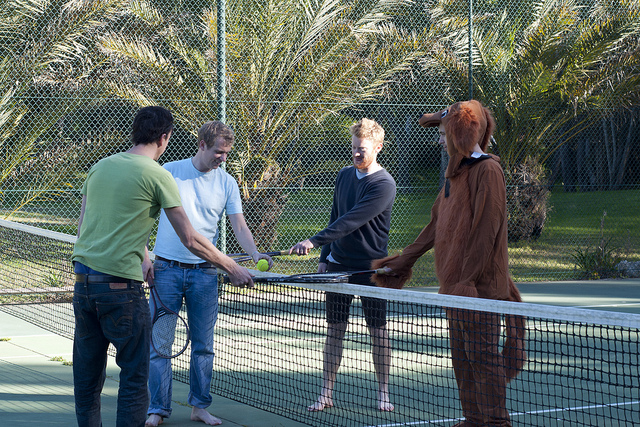Describe the mood of the scene in the image. The mood in the image appears to be light-hearted and fun. The presence of a person in a dog costume adds a playful and humorous element, suggesting that the group is enjoying their time together. The casual attire of the other individuals also indicates a relaxed atmosphere. If you were to write a short story based on this image, what would the plot be? In a small, sunny town, a group of friends gathers every Sunday morning for a match on the local tennis court. This Sunday was special; it was Tim's birthday, and as a surprise, his friends convinced him to wear a dog costume for the game. Laughter echoed as they tried to play a serious match with their furry teammate, turning the game into a hilarious and unforgettable morning. The birthday surprise not only led to a memorable game but also cemented a tradition of themed matches for future Sundays. 